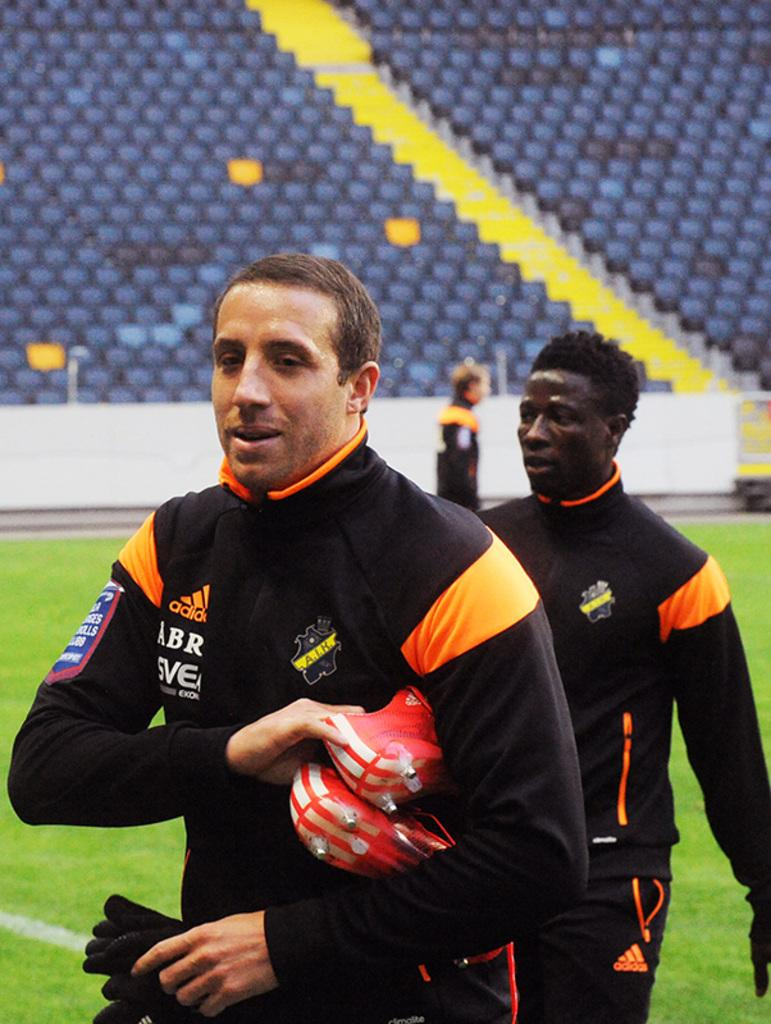How many people are in the image wearing the same dress? There are two people in the image wearing the same dress. What is one of the people holding? One of the people is holding gloves. Can you describe the location of the chairs in the image? The chairs are on a staircase in the image. What type of notebook is being used by the person in the image? There is no notebook present in the image. 